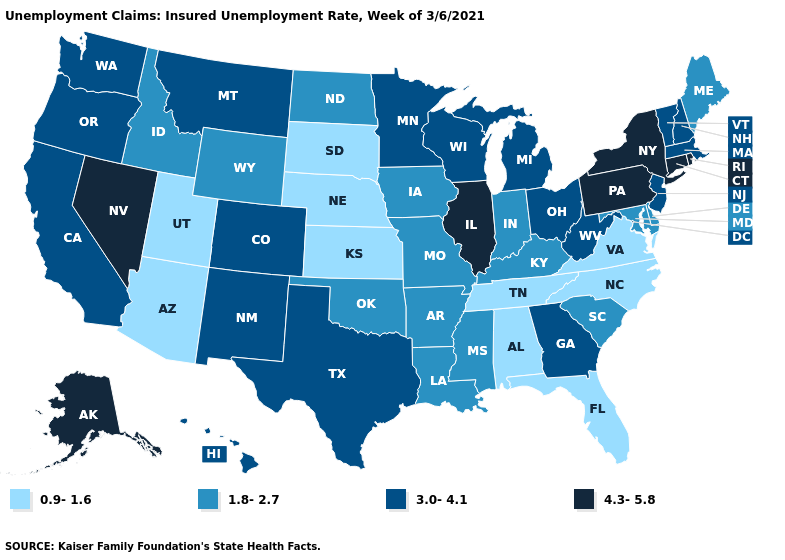Name the states that have a value in the range 1.8-2.7?
Quick response, please. Arkansas, Delaware, Idaho, Indiana, Iowa, Kentucky, Louisiana, Maine, Maryland, Mississippi, Missouri, North Dakota, Oklahoma, South Carolina, Wyoming. Name the states that have a value in the range 3.0-4.1?
Concise answer only. California, Colorado, Georgia, Hawaii, Massachusetts, Michigan, Minnesota, Montana, New Hampshire, New Jersey, New Mexico, Ohio, Oregon, Texas, Vermont, Washington, West Virginia, Wisconsin. Which states have the lowest value in the USA?
Answer briefly. Alabama, Arizona, Florida, Kansas, Nebraska, North Carolina, South Dakota, Tennessee, Utah, Virginia. Name the states that have a value in the range 3.0-4.1?
Give a very brief answer. California, Colorado, Georgia, Hawaii, Massachusetts, Michigan, Minnesota, Montana, New Hampshire, New Jersey, New Mexico, Ohio, Oregon, Texas, Vermont, Washington, West Virginia, Wisconsin. What is the value of Kansas?
Quick response, please. 0.9-1.6. Does the map have missing data?
Answer briefly. No. What is the value of Idaho?
Be succinct. 1.8-2.7. Name the states that have a value in the range 3.0-4.1?
Be succinct. California, Colorado, Georgia, Hawaii, Massachusetts, Michigan, Minnesota, Montana, New Hampshire, New Jersey, New Mexico, Ohio, Oregon, Texas, Vermont, Washington, West Virginia, Wisconsin. What is the value of Michigan?
Be succinct. 3.0-4.1. Among the states that border Vermont , which have the highest value?
Short answer required. New York. Does Oregon have a higher value than Oklahoma?
Quick response, please. Yes. What is the lowest value in states that border Massachusetts?
Short answer required. 3.0-4.1. Which states hav the highest value in the MidWest?
Keep it brief. Illinois. What is the lowest value in states that border Oregon?
Short answer required. 1.8-2.7. 